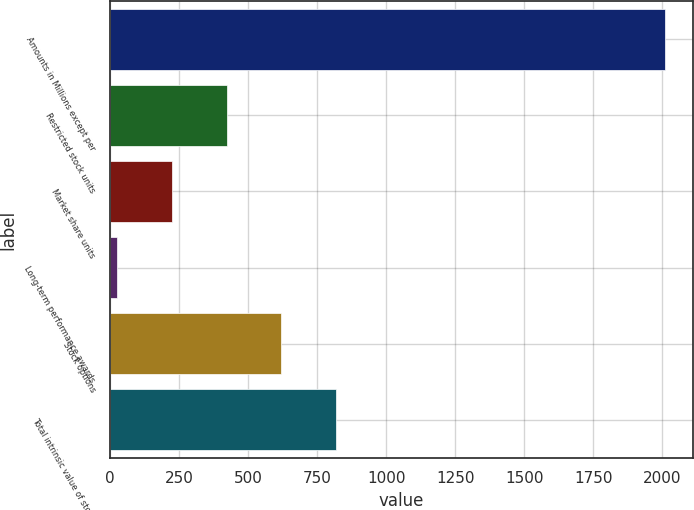Convert chart to OTSL. <chart><loc_0><loc_0><loc_500><loc_500><bar_chart><fcel>Amounts in Millions except per<fcel>Restricted stock units<fcel>Market share units<fcel>Long-term performance awards<fcel>Stock options<fcel>Total intrinsic value of stock<nl><fcel>2011<fcel>422.44<fcel>223.87<fcel>25.3<fcel>621.01<fcel>819.58<nl></chart> 